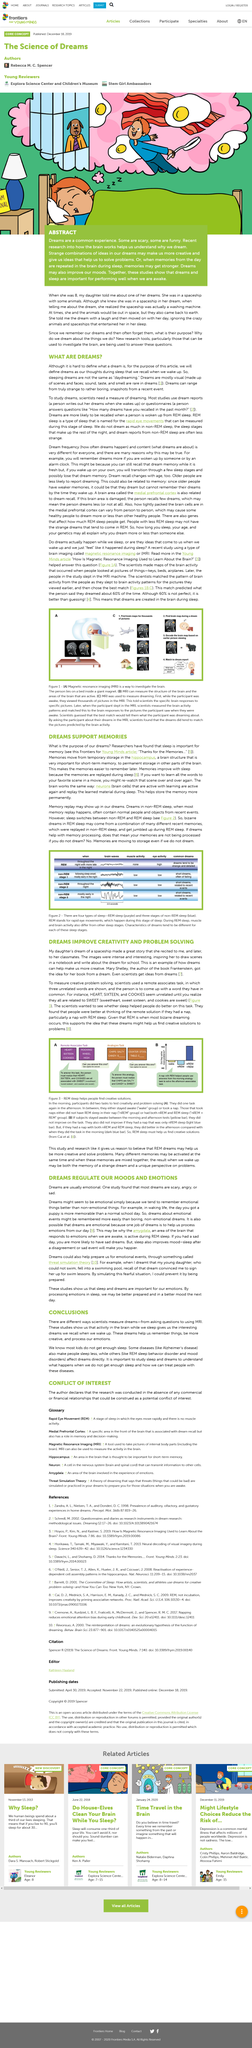Outline some significant characteristics in this image. Dreams can make us more creative. Dreams are created in the brain during sleep, as demonstrated by the study. Memories are still stored even if you do not dream. Magnetic resonance imaging, commonly referred to as MRI, is a medical imaging technique that uses a powerful magnetic field, radio waves, and a computer to produce detailed images of the organs and tissues within the body. Mary Shelley is the author of Frankenstein. 